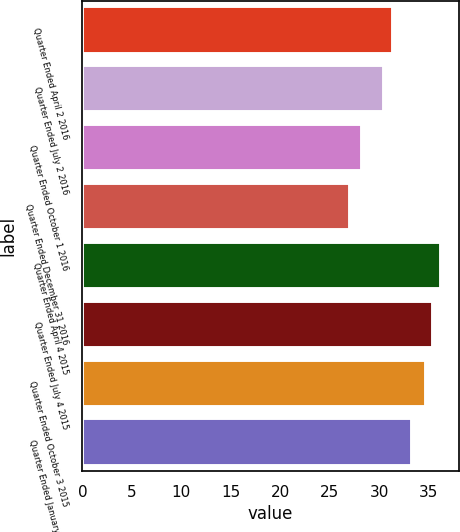Convert chart. <chart><loc_0><loc_0><loc_500><loc_500><bar_chart><fcel>Quarter Ended April 2 2016<fcel>Quarter Ended July 2 2016<fcel>Quarter Ended October 1 2016<fcel>Quarter Ended December 31 2016<fcel>Quarter Ended April 4 2015<fcel>Quarter Ended July 4 2015<fcel>Quarter Ended October 3 2015<fcel>Quarter Ended January 2 2016<nl><fcel>31.36<fcel>30.42<fcel>28.24<fcel>27.07<fcel>36.21<fcel>35.44<fcel>34.67<fcel>33.24<nl></chart> 